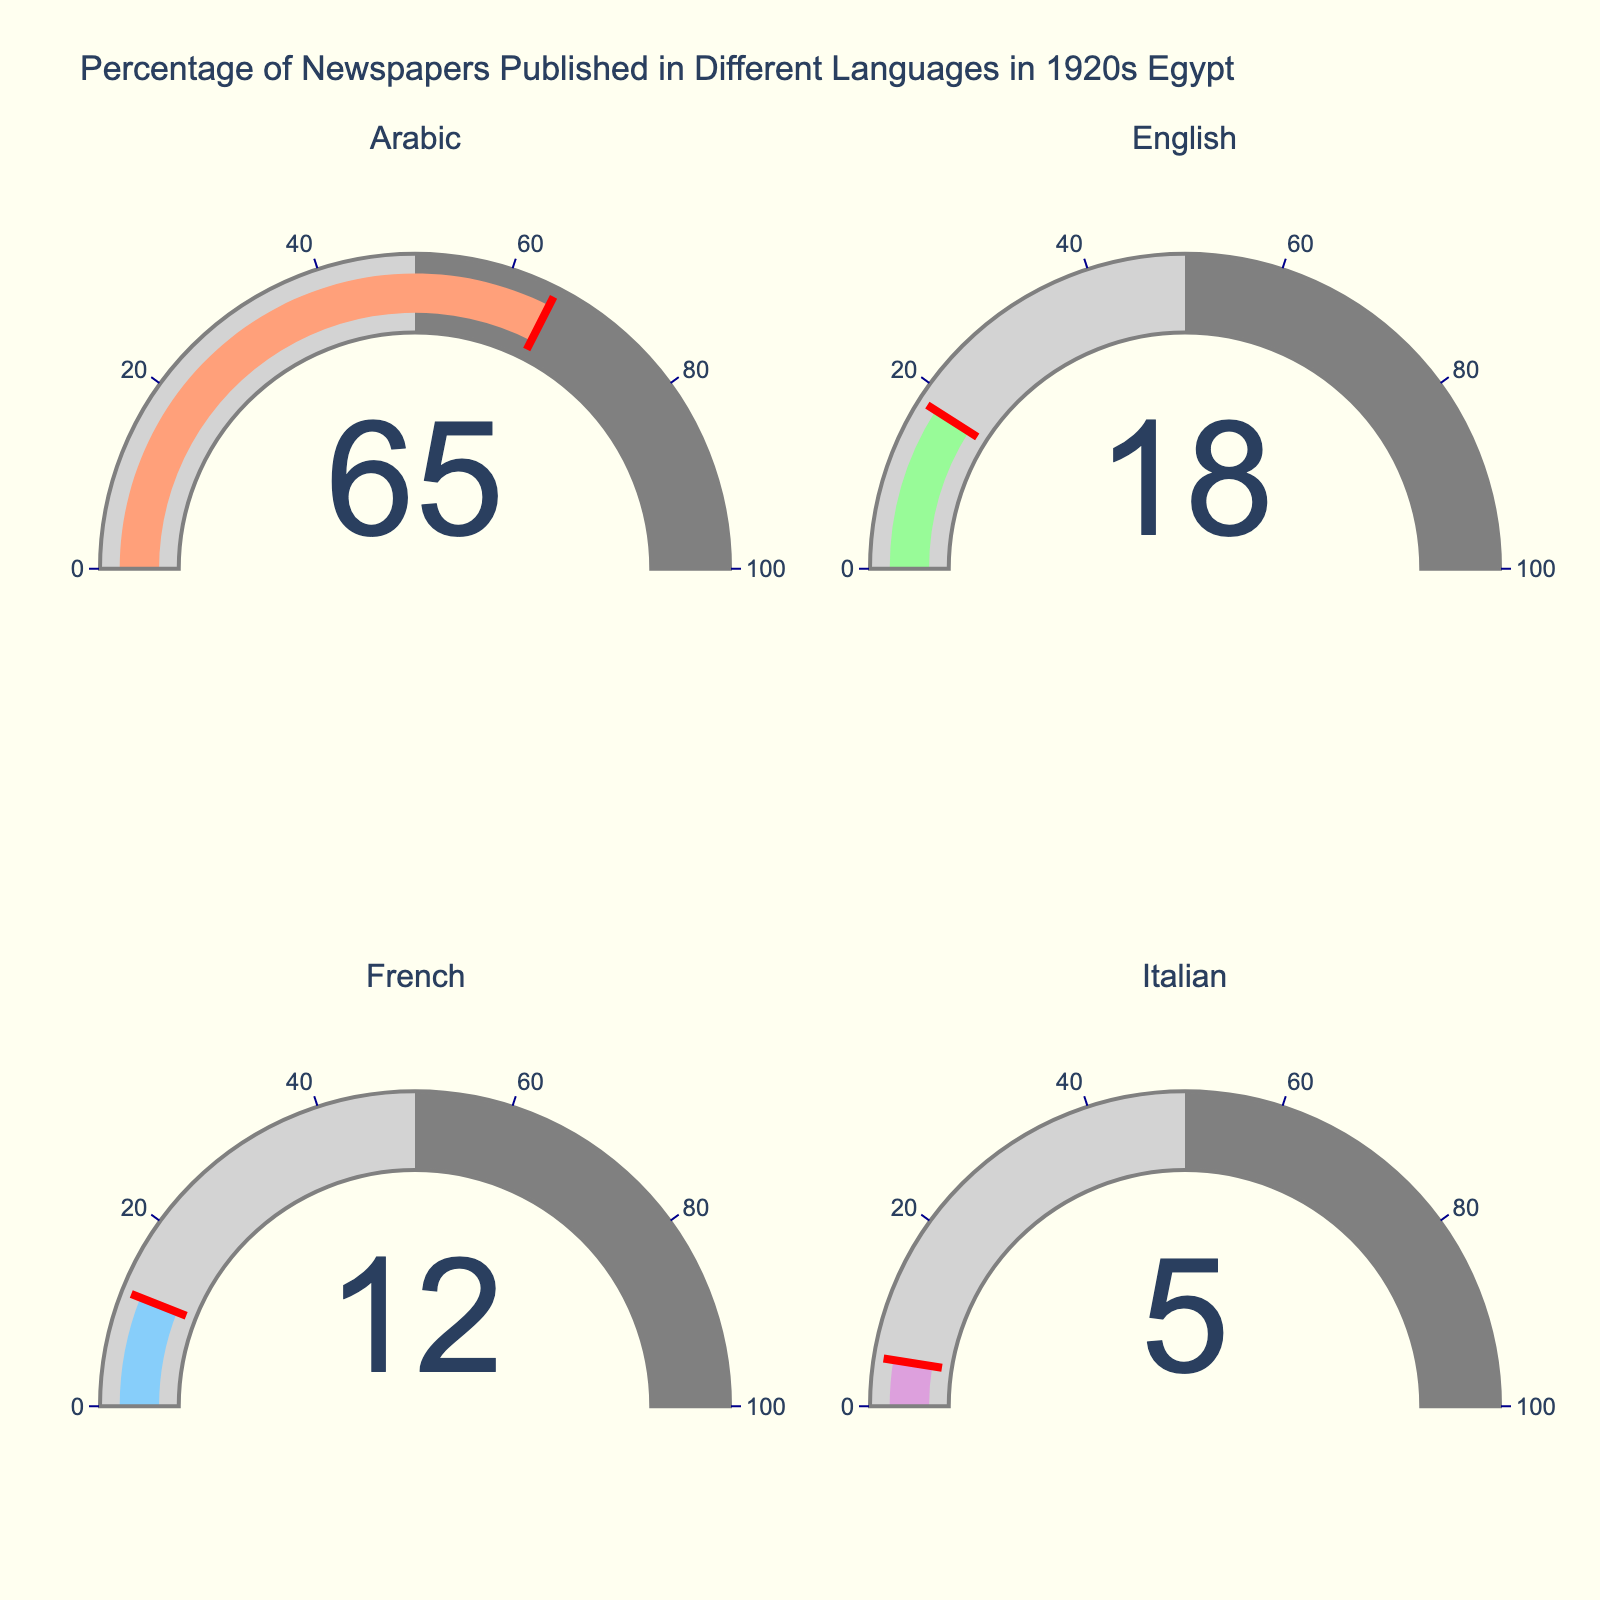What languages are represented in the gauge chart? The chart shows four gauges, each representing a different language: Arabic, English, French, and Italian. This is evident from the subplot titles above each gauge.
Answer: Arabic, English, French, Italian Which language has the highest percentage of newspaper publications? By looking at the values in the gauges, Arabic has the highest percentage with a value of 65%.
Answer: Arabic What is the sum of the percentages for newspapers published in foreign languages? Adding up the percentages for English, French, and Italian: 18% + 12% + 5% equals 35%.
Answer: 35% Is the total percentage of foreign language newspapers more or less than the percentage of Arabic language newspapers? Comparing the total percentage of foreign language newspapers (35%) with Arabic language newspapers (65%), the foreign language newspapers' percentage is less.
Answer: Less Which language gauge has the smallest number? The gauge for Italian has the smallest number, which is 5%.
Answer: Italian How much more is the percentage for Arabic newspapers than French newspapers? Subtract the percentage of French newspapers (12%) from the percentage of Arabic newspapers (65%): 65% - 12% = 53%.
Answer: 53% What is the average percentage of newspapers published in English and French? Adding the percentages for English (18%) and French (12%) and dividing by 2: (18% + 12%) / 2 = 15%.
Answer: 15% Are there any languages that have a percentage below 10%? Among the languages, only Italian has a percentage below 10%, which is 5%.
Answer: Yes How much greater is the percentage of English newspapers compared to Italian newspapers? Subtract the percentage of Italian newspapers (5%) from the percentage of English newspapers (18%): 18% - 5% = 13%.
Answer: 13% If the gauge for Arabic newspapers has a threshold line at its percentage value, where would this line fall? The threshold line for Arabic newspapers would fall at 65%, as the gauge value indicates 65%.
Answer: 65% 